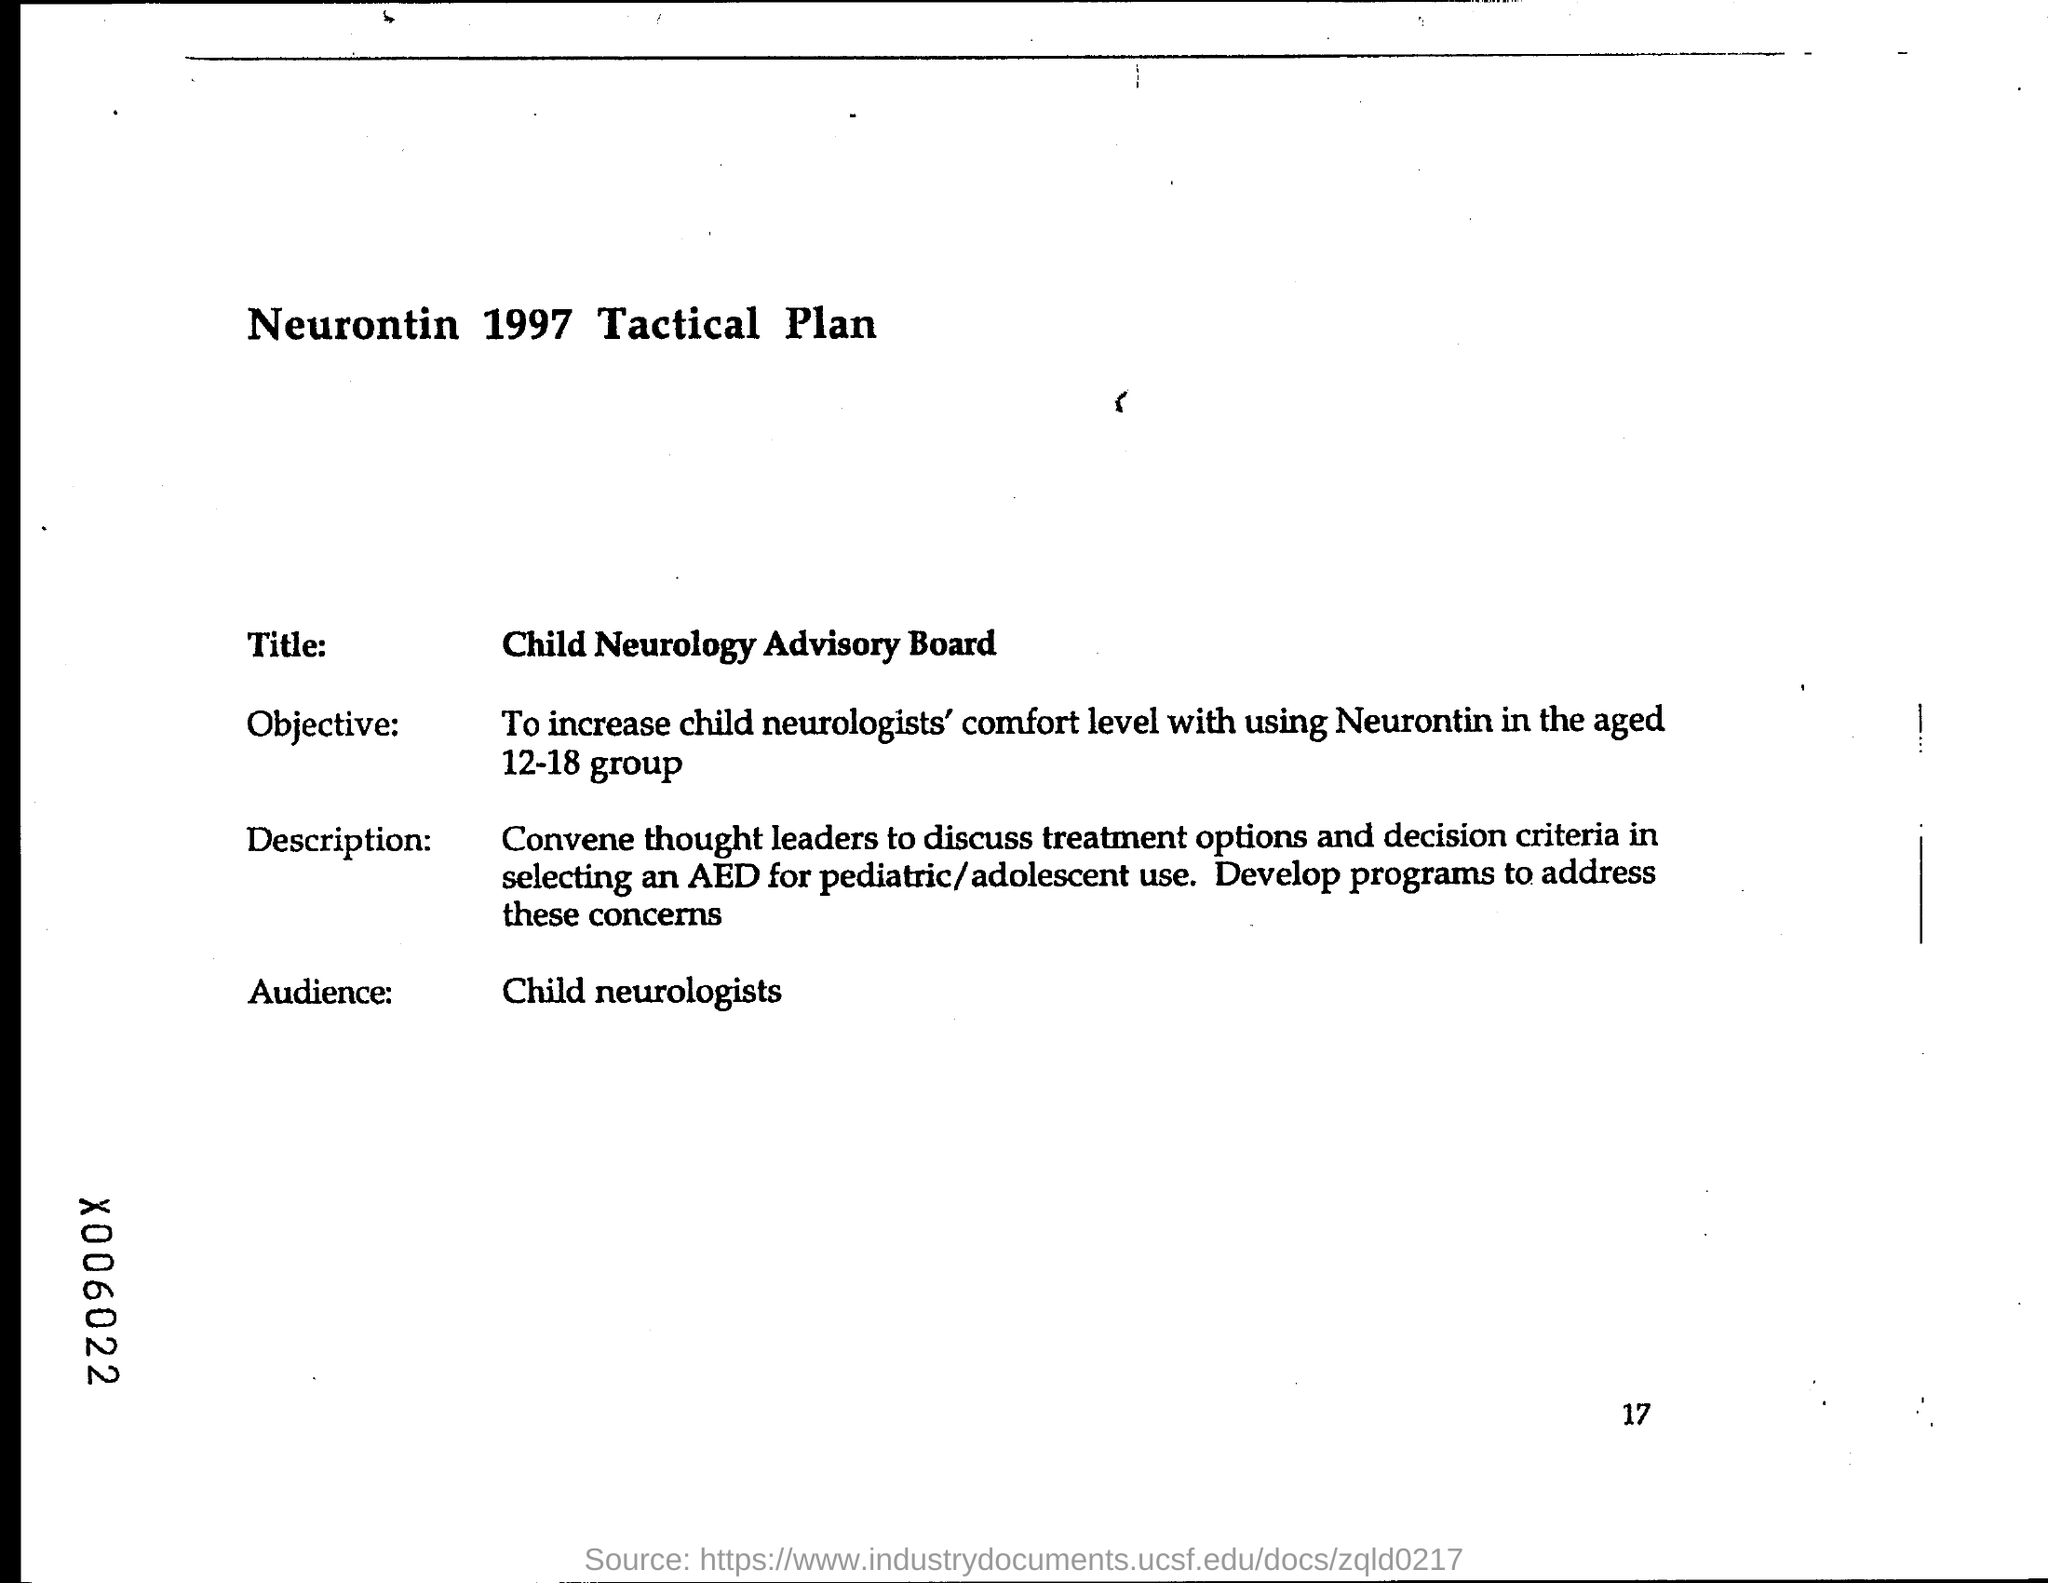What is the Title?
Your answer should be compact. Child Neurology Advisory Board. Which year is mentioned in the heading of the document?
Make the answer very short. 1997. Who is the Audience?
Provide a short and direct response. Child neurologists. What is the Objective?
Offer a terse response. To increase child neurologists comfort level with using Neurontin in the aged 12-18 group. 